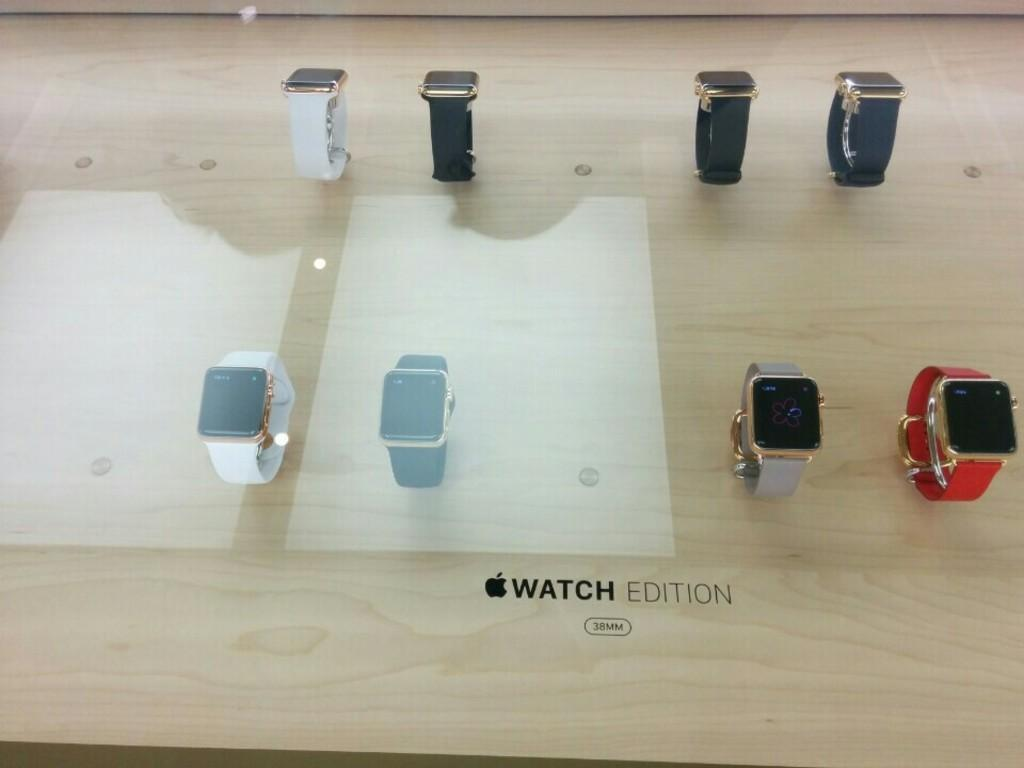What type of table is visible in the image? There is a glass table in the image. What items are placed on the table? There are smart watches of different colors in the image. Is there any additional information or marking on the image? Yes, there is a watermark at the bottom of the image. What activity is the person doing on the sidewalk in the image? There is no person or sidewalk present in the image; it only features a glass table with smart watches on it and a watermark at the bottom. 